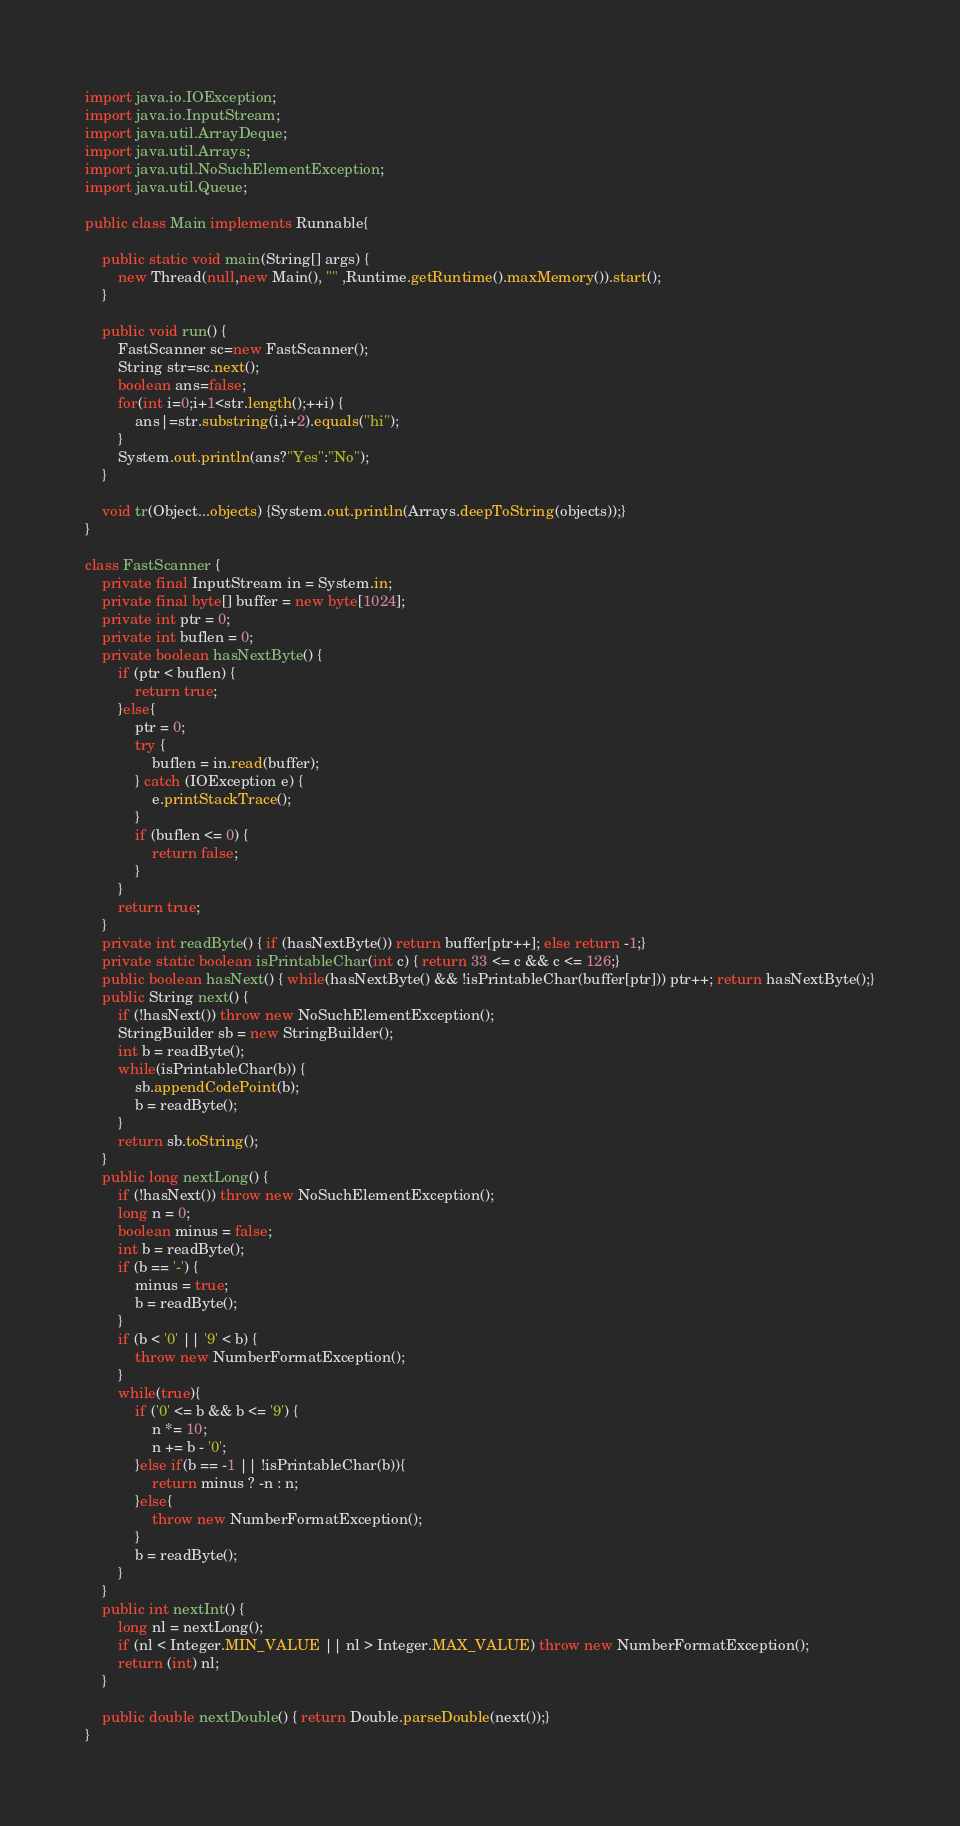Convert code to text. <code><loc_0><loc_0><loc_500><loc_500><_Java_>import java.io.IOException;
import java.io.InputStream;
import java.util.ArrayDeque;
import java.util.Arrays;
import java.util.NoSuchElementException;
import java.util.Queue;

public class Main implements Runnable{

	public static void main(String[] args) {
		new Thread(null,new Main(), "" ,Runtime.getRuntime().maxMemory()).start();
	}
	
	public void run() {
		FastScanner sc=new FastScanner();
		String str=sc.next();
		boolean ans=false;
		for(int i=0;i+1<str.length();++i) {
			ans|=str.substring(i,i+2).equals("hi");
		}
		System.out.println(ans?"Yes":"No");
	}
	
	void tr(Object...objects) {System.out.println(Arrays.deepToString(objects));}
}

class FastScanner {
    private final InputStream in = System.in;
    private final byte[] buffer = new byte[1024];
    private int ptr = 0;
    private int buflen = 0;
    private boolean hasNextByte() {
        if (ptr < buflen) {
            return true;
        }else{
            ptr = 0;
            try {
                buflen = in.read(buffer);
            } catch (IOException e) {
                e.printStackTrace();
            }
            if (buflen <= 0) {
                return false;
            }
        }
        return true;
    }
    private int readByte() { if (hasNextByte()) return buffer[ptr++]; else return -1;}
    private static boolean isPrintableChar(int c) { return 33 <= c && c <= 126;}
    public boolean hasNext() { while(hasNextByte() && !isPrintableChar(buffer[ptr])) ptr++; return hasNextByte();}
    public String next() {
        if (!hasNext()) throw new NoSuchElementException();
        StringBuilder sb = new StringBuilder();
        int b = readByte();
        while(isPrintableChar(b)) {
            sb.appendCodePoint(b);
            b = readByte();
        }
        return sb.toString();
    }
    public long nextLong() {
        if (!hasNext()) throw new NoSuchElementException();
        long n = 0;
        boolean minus = false;
        int b = readByte();
        if (b == '-') {
            minus = true;
            b = readByte();
        }
        if (b < '0' || '9' < b) {
            throw new NumberFormatException();
        }
        while(true){
            if ('0' <= b && b <= '9') {
                n *= 10;
                n += b - '0';
            }else if(b == -1 || !isPrintableChar(b)){
                return minus ? -n : n;
            }else{
                throw new NumberFormatException();
            }
            b = readByte();
        }
    }
    public int nextInt() {
        long nl = nextLong();
        if (nl < Integer.MIN_VALUE || nl > Integer.MAX_VALUE) throw new NumberFormatException();
        return (int) nl;
    }
    
    public double nextDouble() { return Double.parseDouble(next());}
}</code> 